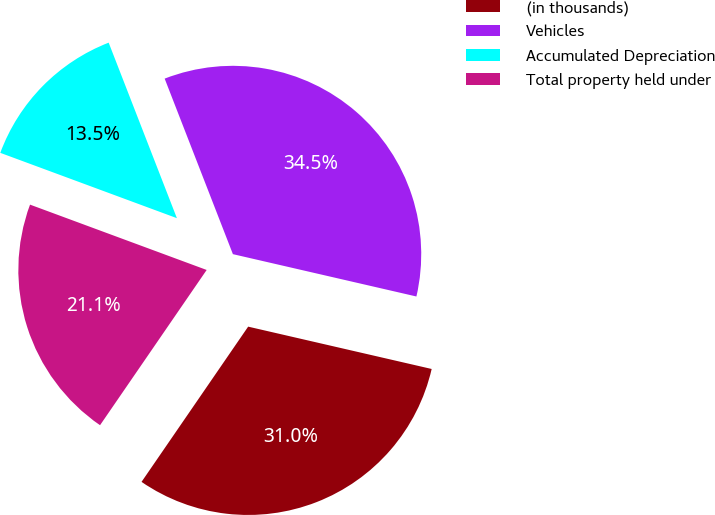Convert chart to OTSL. <chart><loc_0><loc_0><loc_500><loc_500><pie_chart><fcel>(in thousands)<fcel>Vehicles<fcel>Accumulated Depreciation<fcel>Total property held under<nl><fcel>30.97%<fcel>34.51%<fcel>13.46%<fcel>21.06%<nl></chart> 